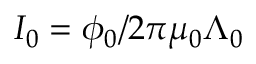<formula> <loc_0><loc_0><loc_500><loc_500>I _ { 0 } = \phi _ { 0 } / 2 \pi \mu _ { 0 } \Lambda _ { 0 }</formula> 